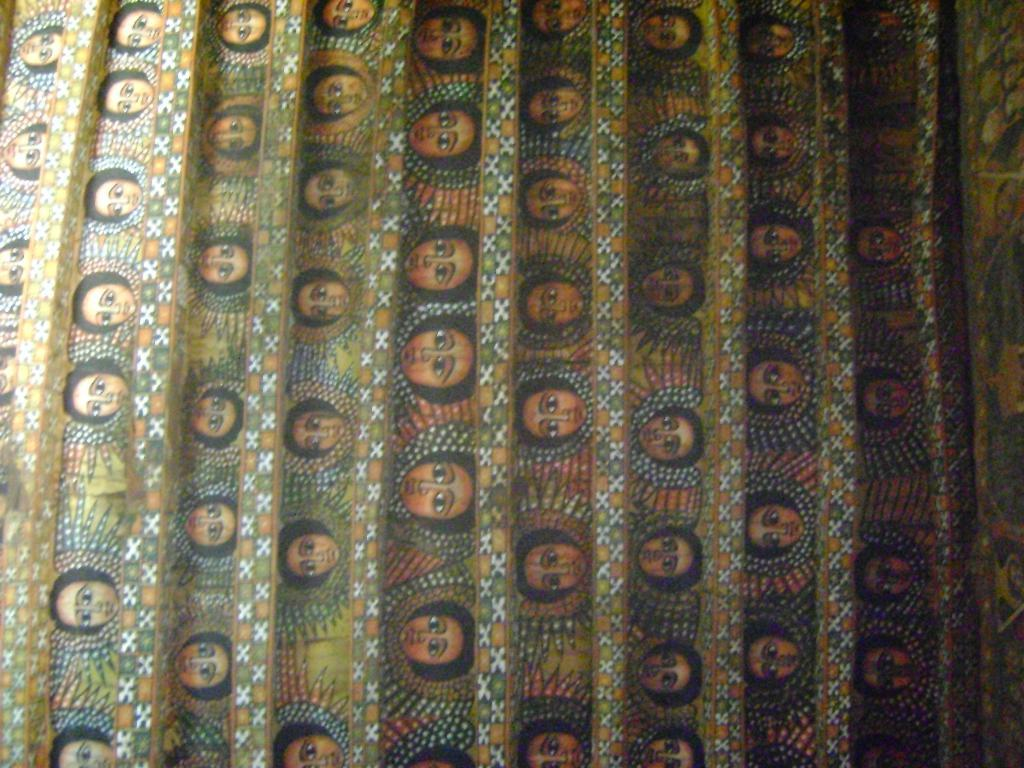What is the main object in the image? There is a cloth in the image. Can you describe the appearance of the cloth? The cloth has designs on it. What can be seen on the designs of the cloth? There are faces of persons visible on the cloth. How is the distribution of the horns on the cloth determined? There are no horns present on the cloth in the image. 